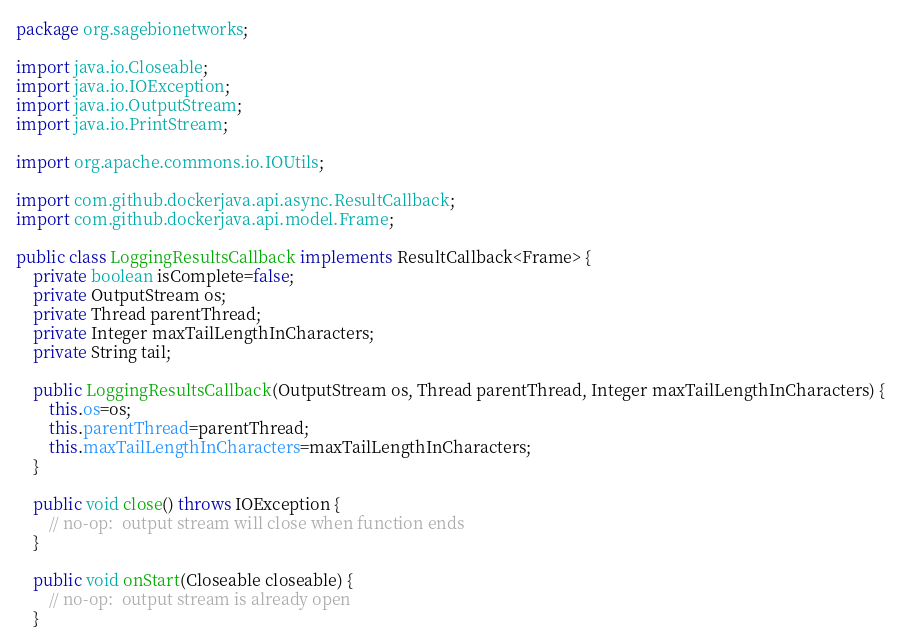<code> <loc_0><loc_0><loc_500><loc_500><_Java_>package org.sagebionetworks;

import java.io.Closeable;
import java.io.IOException;
import java.io.OutputStream;
import java.io.PrintStream;

import org.apache.commons.io.IOUtils;

import com.github.dockerjava.api.async.ResultCallback;
import com.github.dockerjava.api.model.Frame;

public class LoggingResultsCallback implements ResultCallback<Frame> {
	private boolean isComplete=false;
	private OutputStream os;
	private Thread parentThread;
	private Integer maxTailLengthInCharacters;
	private String tail;

	public LoggingResultsCallback(OutputStream os, Thread parentThread, Integer maxTailLengthInCharacters) {
		this.os=os;
		this.parentThread=parentThread;
		this.maxTailLengthInCharacters=maxTailLengthInCharacters;
	}

	public void close() throws IOException {
		// no-op:  output stream will close when function ends
	}

	public void onStart(Closeable closeable) {
		// no-op:  output stream is already open
	}
</code> 